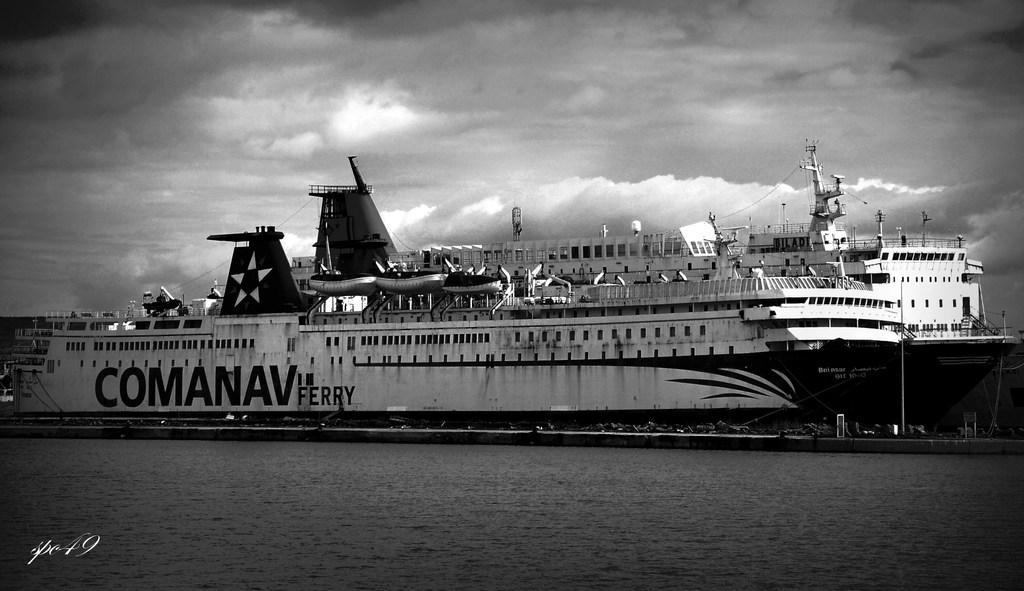<image>
Provide a brief description of the given image. Large ship on the waters with the name COMANAV FERRY on the side. 